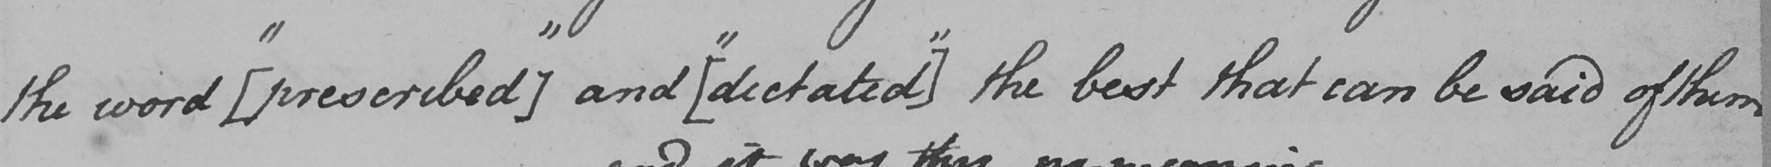Please provide the text content of this handwritten line. the word  [  " prescribed "  ]  and  [  " dictated "  ]  the best that can be said of them 